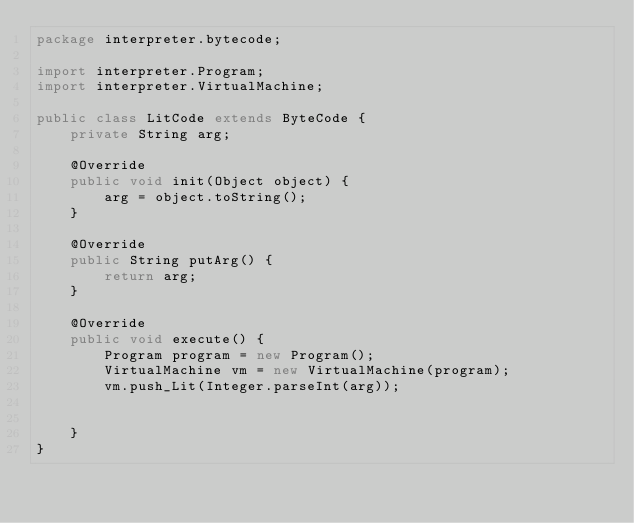<code> <loc_0><loc_0><loc_500><loc_500><_Java_>package interpreter.bytecode;

import interpreter.Program;
import interpreter.VirtualMachine;

public class LitCode extends ByteCode {
    private String arg;

    @Override
    public void init(Object object) {
        arg = object.toString();
    }

    @Override
    public String putArg() {
        return arg;
    }

    @Override
    public void execute() {
        Program program = new Program();
        VirtualMachine vm = new VirtualMachine(program);
        vm.push_Lit(Integer.parseInt(arg));


    }
}
</code> 